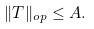<formula> <loc_0><loc_0><loc_500><loc_500>\| T \| _ { o p } \leq A .</formula> 